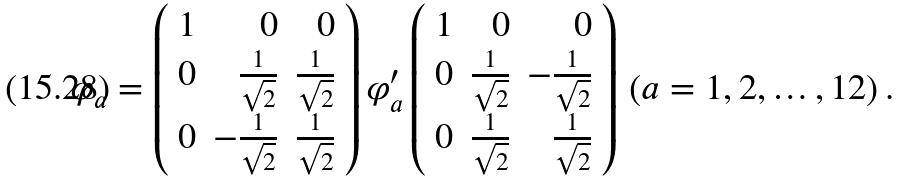<formula> <loc_0><loc_0><loc_500><loc_500>\varphi _ { a } = \left ( \begin{array} { r r r } 1 & 0 & 0 \\ 0 & \frac { 1 } { \sqrt { 2 } } & \frac { 1 } { \sqrt { 2 } } \\ 0 & - \frac { 1 } { \sqrt { 2 } } & \frac { 1 } { \sqrt { 2 } } \end{array} \right ) \varphi ^ { \prime } _ { a } \left ( \begin{array} { r r r } 1 & 0 & 0 \\ 0 & \frac { 1 } { \sqrt { 2 } } & - \frac { 1 } { \sqrt { 2 } } \\ 0 & \frac { 1 } { \sqrt { 2 } } & \frac { 1 } { \sqrt { 2 } } \end{array} \right ) \, ( a = 1 , 2 , \dots , 1 2 ) \, .</formula> 